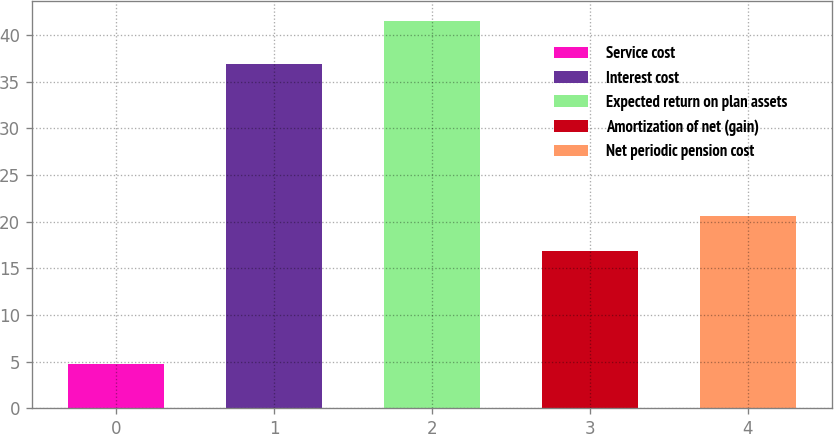Convert chart. <chart><loc_0><loc_0><loc_500><loc_500><bar_chart><fcel>Service cost<fcel>Interest cost<fcel>Expected return on plan assets<fcel>Amortization of net (gain)<fcel>Net periodic pension cost<nl><fcel>4.7<fcel>36.9<fcel>41.5<fcel>16.9<fcel>20.58<nl></chart> 